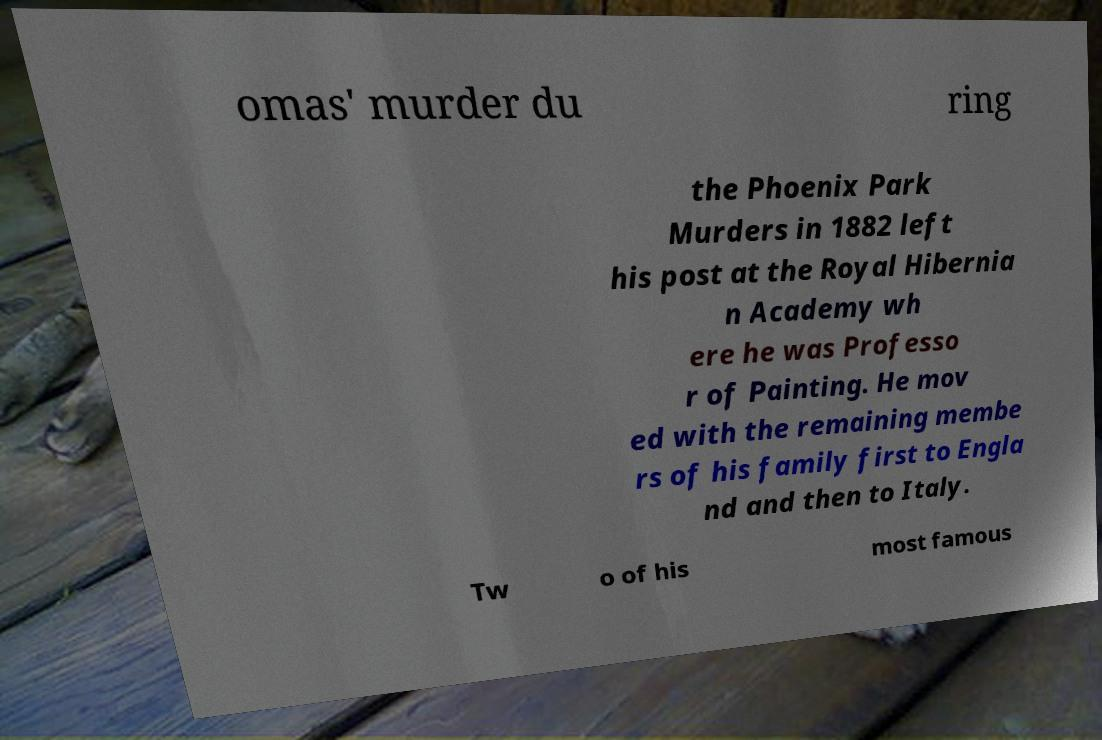Can you read and provide the text displayed in the image?This photo seems to have some interesting text. Can you extract and type it out for me? omas' murder du ring the Phoenix Park Murders in 1882 left his post at the Royal Hibernia n Academy wh ere he was Professo r of Painting. He mov ed with the remaining membe rs of his family first to Engla nd and then to Italy. Tw o of his most famous 